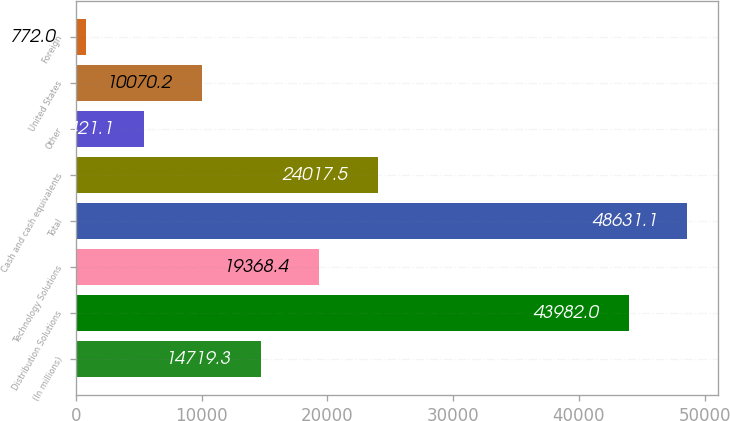Convert chart. <chart><loc_0><loc_0><loc_500><loc_500><bar_chart><fcel>(In millions)<fcel>Distribution Solutions<fcel>Technology Solutions<fcel>Total<fcel>Cash and cash equivalents<fcel>Other<fcel>United States<fcel>Foreign<nl><fcel>14719.3<fcel>43982<fcel>19368.4<fcel>48631.1<fcel>24017.5<fcel>5421.1<fcel>10070.2<fcel>772<nl></chart> 